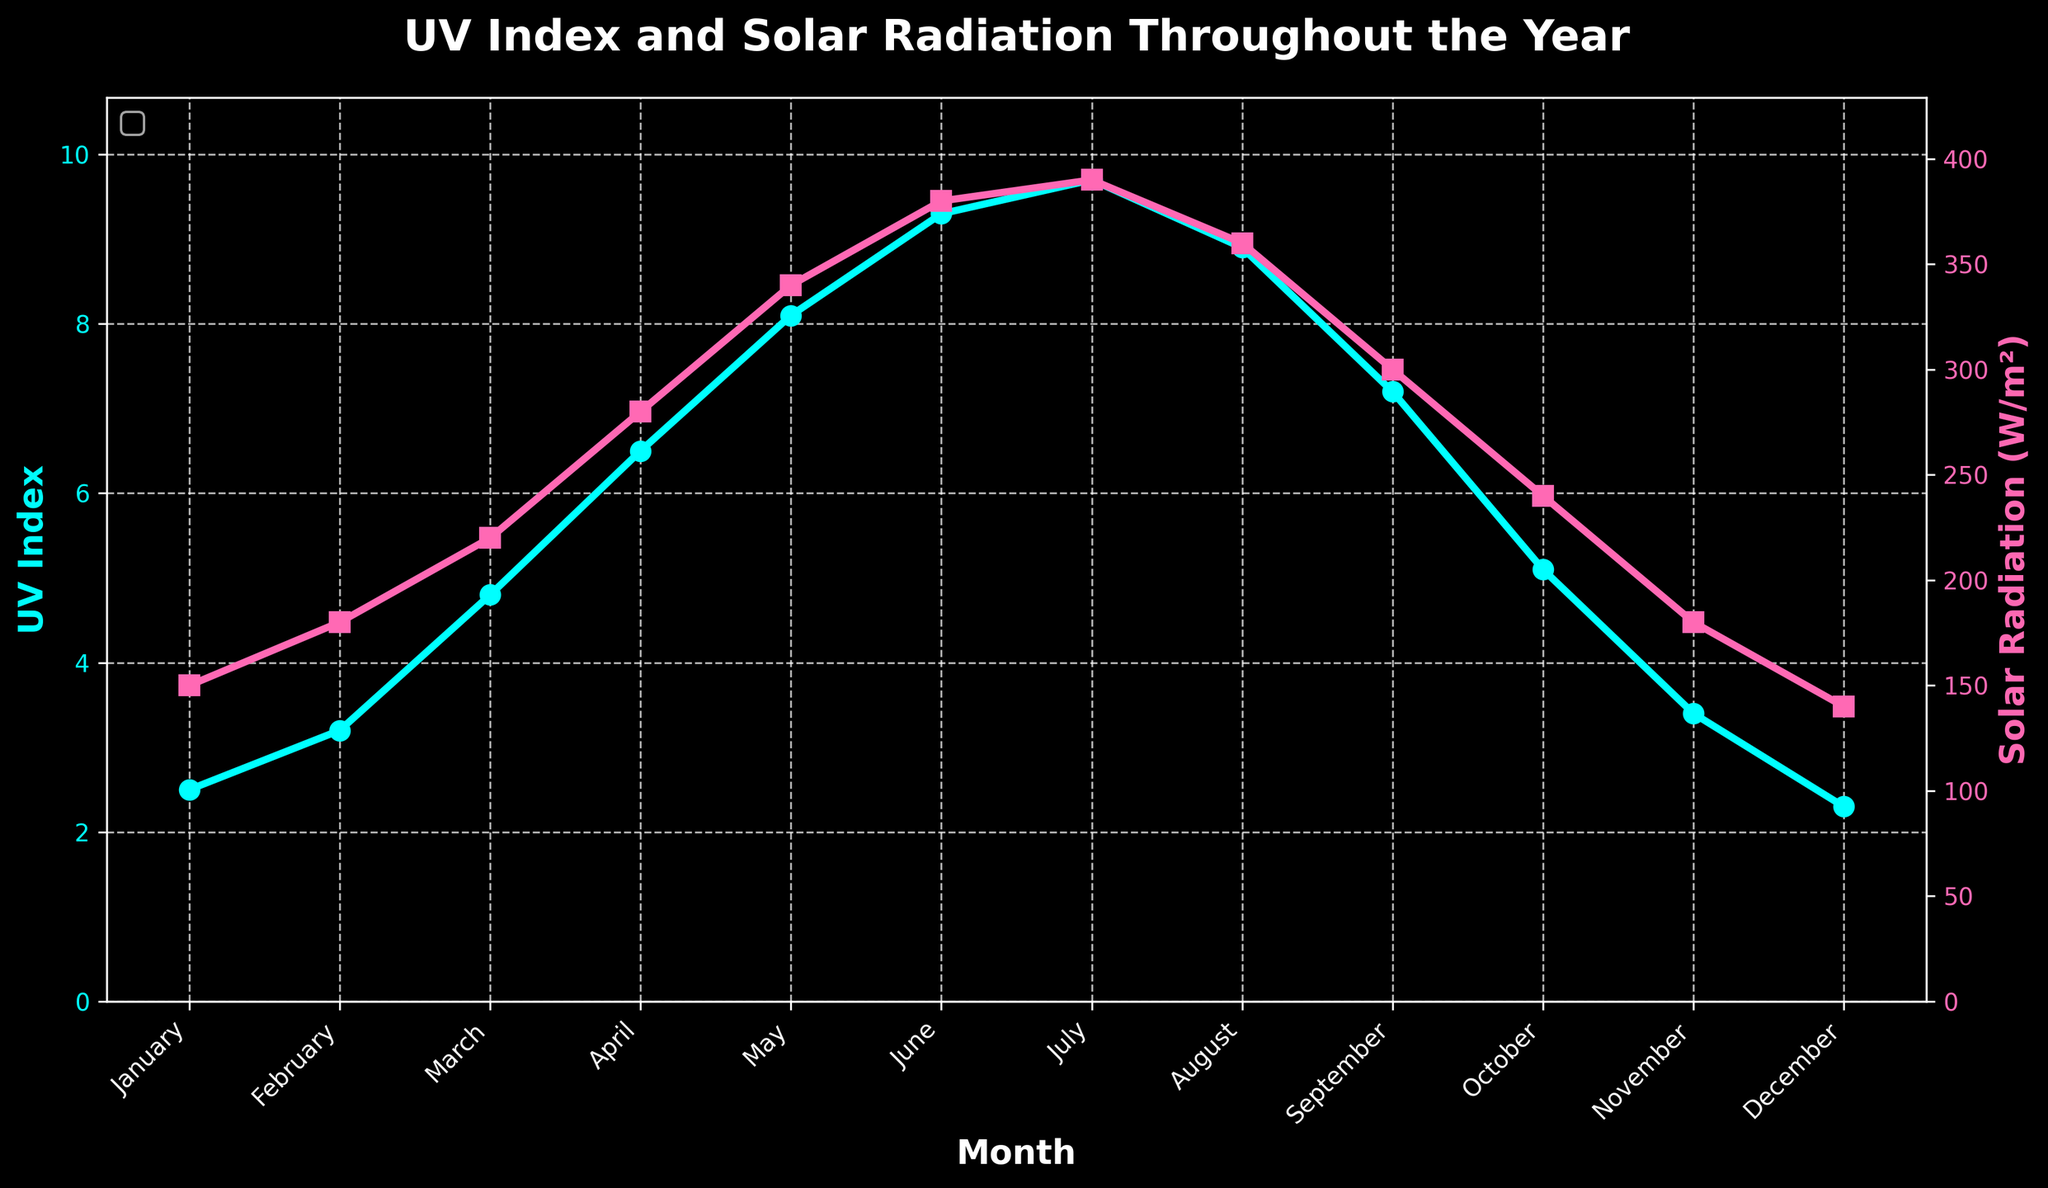What is the trend of the UV Index over the months? The UV Index generally increases from January to July, reaching a peak in July, and then decreases from August to December.
Answer: Increases until July, then decreases What month has the highest solar radiation? The highest solar radiation is indicated by the peak point on the solar radiation curve, which occurs in July at 390 W/m².
Answer: July In which months are both the UV Index and solar radiation simultaneously increasing? Both the UV Index and solar radiation show an increasing trend from January to July. Break this down by noting both metrics' incremental rise month-on-month within this period.
Answer: January to July Compare the UV Index in December and August. The UV Index is observed to be higher in August (8.9) than in December (2.3) by looking at the points on the UV Index curve for these months.
Answer: August > December What is the average UV Index in the summer months (June, July, and August)? Sum the UV Index values for June, July, and August (9.3 + 9.7 + 8.9) and divide by 3. (9.3 + 9.7 + 8.9) / 3 = 9.3
Answer: 9.3 How does the UV Index in October compare to April? Compare the UV Index values directly from the plot. UV Index in April is 6.5, and in October it is 5.1, so April's UV Index is higher.
Answer: April > October What is the range of solar radiation throughout the year? Find the minimum and maximum values of the solar radiation curve. The minimum is 140 W/m² in December, and the maximum is 390 W/m² in July. The range is the difference between these values (390 - 140).
Answer: 250 W/m² Identify the months where the UV Index is greater than 4. From the plot, the UV Index is greater than 4 during March, April, May, June, July, August, and September.
Answer: March to September 